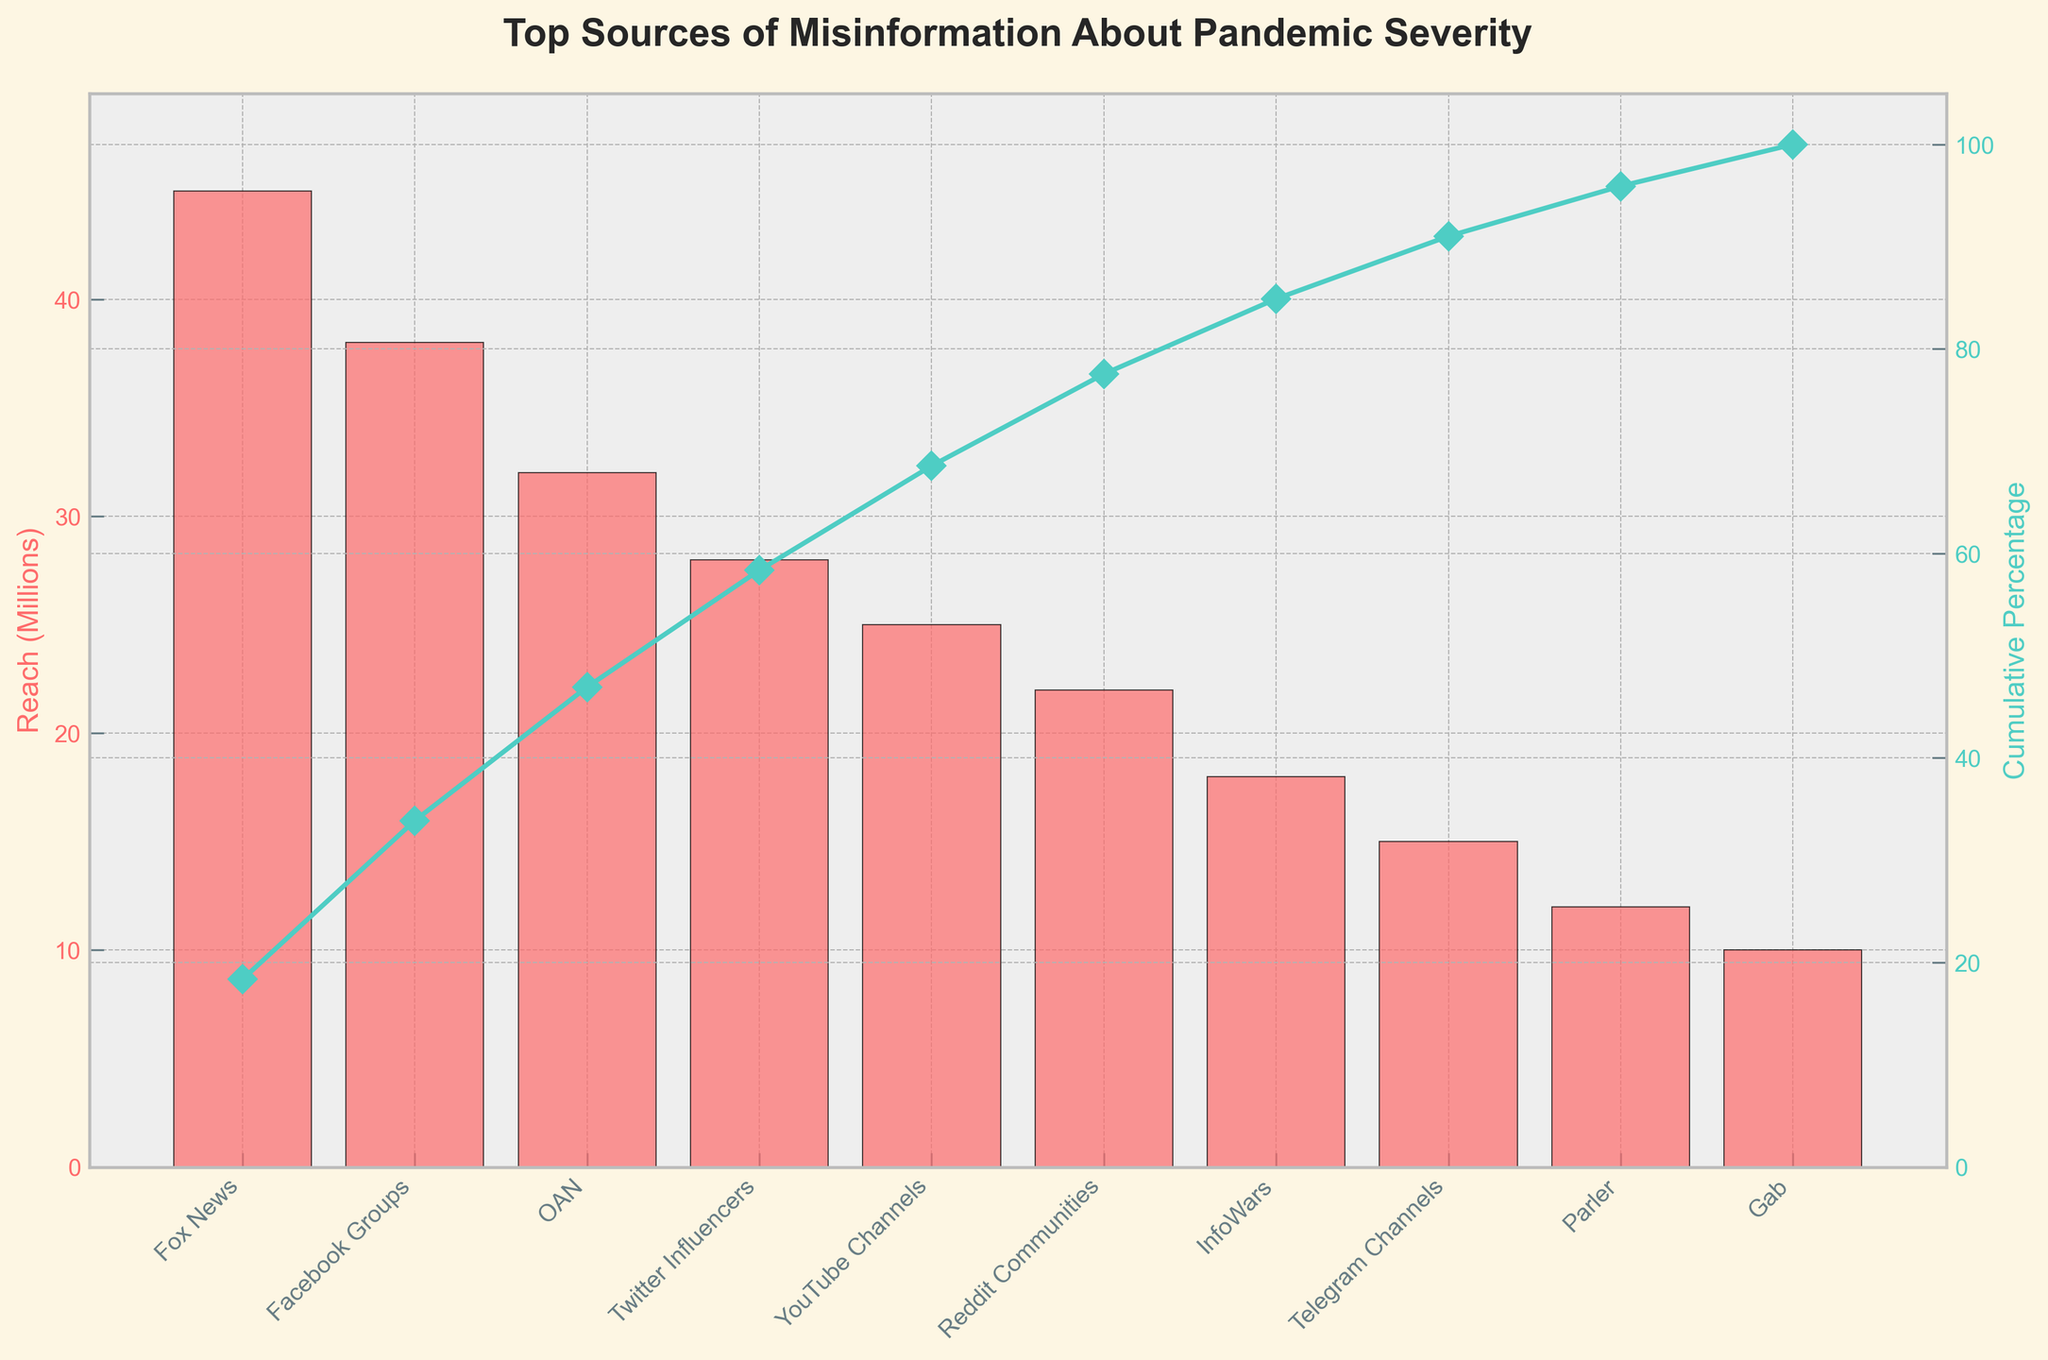What is the title of the figure? The title is prominently displayed at the top of the figure. It summarizes the main idea of what the figure represents.
Answer: Top Sources of Misinformation About Pandemic Severity What is the source with the highest reach? The source with the highest bar value corresponds to the highest reach in millions.
Answer: Fox News How many sources have a reach of 25 million or more? Identify the sources with bar values of 25 million or higher and count them.
Answer: Four (Fox News, Facebook Groups, OAN, Twitter Influencers) What is the total reach of the top three sources combined? Add the reach values of the top three sources: Fox News (45), Facebook Groups (38), and OAN (32).
Answer: 115 million Which source sits at the 70% cumulative percentage mark? Locate the point where the cumulative percentage curve intersects the 70% mark on the y-axis and match it to the corresponding source on the x-axis.
Answer: YouTube Channels What is the cumulative percentage reached by InfoWars? Follow the cumulative percentage line corresponding to InfoWars.
Answer: 92% Which has a greater reach, Reddit Communities or Telegram Channels? Compare the bar heights of Reddit Communities and Telegram Channels.
Answer: Reddit Communities How many sources contribute to reaching 50% cumulative percentage? Count the sources along the x-axis up to the point where the cumulative percentage curve first reaches or exceeds 50%.
Answer: Three (Fox News, Facebook Groups, OAN) What is the smallest reach value depicted in the figure? Identify the shortest bar in the figure to find the smallest reach value.
Answer: 10 million (Gab) Do Parler and InfoWars combined reach more people than Fox News? Add the reach values of Parler and InfoWars, and compare the sum to Fox News’s reach.
Answer: No (Parler + InfoWars = 30 million, Fox News = 45 million) 